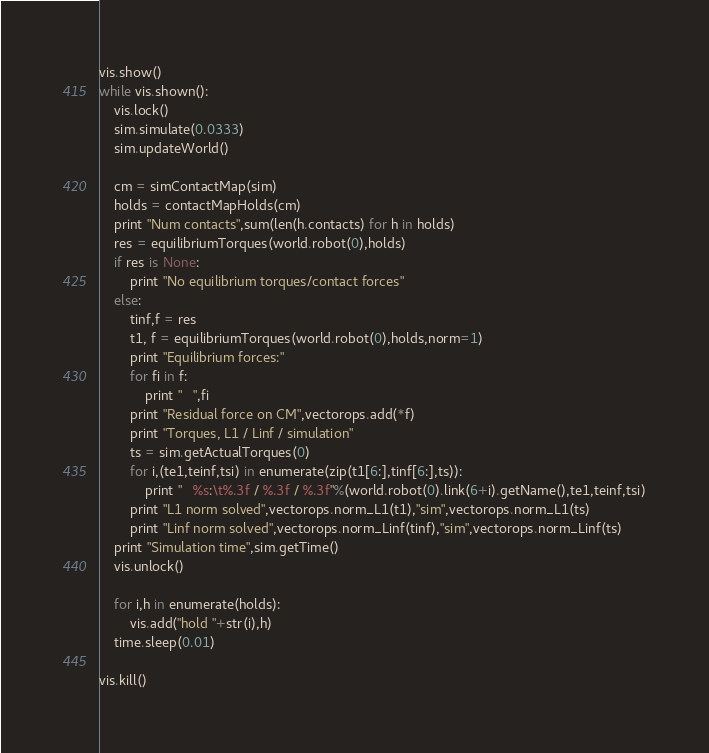Convert code to text. <code><loc_0><loc_0><loc_500><loc_500><_Python_>vis.show()
while vis.shown():
	vis.lock()
	sim.simulate(0.0333)
	sim.updateWorld()

	cm = simContactMap(sim)
	holds = contactMapHolds(cm)
	print "Num contacts",sum(len(h.contacts) for h in holds)
	res = equilibriumTorques(world.robot(0),holds)
	if res is None:
		print "No equilibrium torques/contact forces"
	else:
		tinf,f = res
		t1, f = equilibriumTorques(world.robot(0),holds,norm=1)
		print "Equilibrium forces:"
		for fi in f:
			print "   ",fi
		print "Residual force on CM",vectorops.add(*f)
		print "Torques, L1 / Linf / simulation"
		ts = sim.getActualTorques(0)
		for i,(te1,teinf,tsi) in enumerate(zip(t1[6:],tinf[6:],ts)):
			print "   %s:\t%.3f / %.3f / %.3f"%(world.robot(0).link(6+i).getName(),te1,teinf,tsi)
		print "L1 norm solved",vectorops.norm_L1(t1),"sim",vectorops.norm_L1(ts)
		print "Linf norm solved",vectorops.norm_Linf(tinf),"sim",vectorops.norm_Linf(ts)
	print "Simulation time",sim.getTime()
	vis.unlock()
	
	for i,h in enumerate(holds):
		vis.add("hold "+str(i),h)
	time.sleep(0.01)

vis.kill()

</code> 